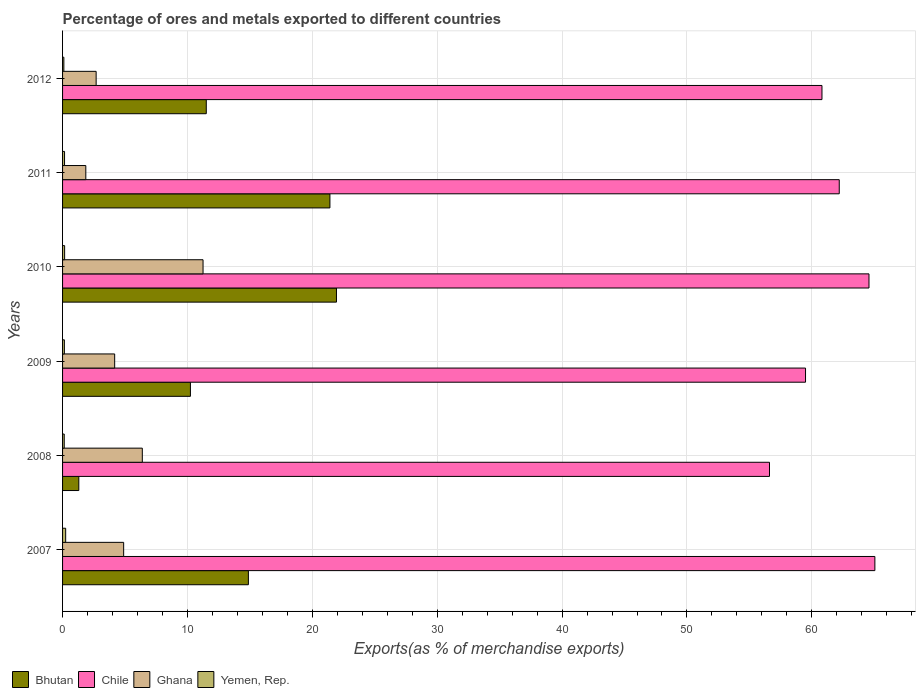Are the number of bars per tick equal to the number of legend labels?
Provide a succinct answer. Yes. How many bars are there on the 1st tick from the top?
Offer a very short reply. 4. How many bars are there on the 1st tick from the bottom?
Ensure brevity in your answer.  4. In how many cases, is the number of bars for a given year not equal to the number of legend labels?
Make the answer very short. 0. What is the percentage of exports to different countries in Chile in 2008?
Your answer should be very brief. 56.61. Across all years, what is the maximum percentage of exports to different countries in Ghana?
Your answer should be very brief. 11.25. Across all years, what is the minimum percentage of exports to different countries in Ghana?
Your response must be concise. 1.86. In which year was the percentage of exports to different countries in Chile maximum?
Your answer should be compact. 2007. In which year was the percentage of exports to different countries in Yemen, Rep. minimum?
Ensure brevity in your answer.  2012. What is the total percentage of exports to different countries in Yemen, Rep. in the graph?
Your response must be concise. 0.95. What is the difference between the percentage of exports to different countries in Chile in 2009 and that in 2010?
Keep it short and to the point. -5.08. What is the difference between the percentage of exports to different countries in Bhutan in 2008 and the percentage of exports to different countries in Yemen, Rep. in 2007?
Make the answer very short. 1.05. What is the average percentage of exports to different countries in Bhutan per year?
Provide a short and direct response. 13.55. In the year 2012, what is the difference between the percentage of exports to different countries in Bhutan and percentage of exports to different countries in Yemen, Rep.?
Ensure brevity in your answer.  11.4. What is the ratio of the percentage of exports to different countries in Yemen, Rep. in 2008 to that in 2011?
Provide a succinct answer. 0.85. Is the difference between the percentage of exports to different countries in Bhutan in 2008 and 2011 greater than the difference between the percentage of exports to different countries in Yemen, Rep. in 2008 and 2011?
Your response must be concise. No. What is the difference between the highest and the second highest percentage of exports to different countries in Yemen, Rep.?
Ensure brevity in your answer.  0.08. What is the difference between the highest and the lowest percentage of exports to different countries in Yemen, Rep.?
Give a very brief answer. 0.15. In how many years, is the percentage of exports to different countries in Chile greater than the average percentage of exports to different countries in Chile taken over all years?
Provide a short and direct response. 3. Is the sum of the percentage of exports to different countries in Yemen, Rep. in 2007 and 2012 greater than the maximum percentage of exports to different countries in Bhutan across all years?
Your answer should be compact. No. Is it the case that in every year, the sum of the percentage of exports to different countries in Yemen, Rep. and percentage of exports to different countries in Ghana is greater than the sum of percentage of exports to different countries in Chile and percentage of exports to different countries in Bhutan?
Your response must be concise. Yes. What does the 1st bar from the top in 2009 represents?
Your answer should be very brief. Yemen, Rep. What does the 1st bar from the bottom in 2009 represents?
Ensure brevity in your answer.  Bhutan. Is it the case that in every year, the sum of the percentage of exports to different countries in Ghana and percentage of exports to different countries in Bhutan is greater than the percentage of exports to different countries in Chile?
Provide a succinct answer. No. Are all the bars in the graph horizontal?
Provide a succinct answer. Yes. What is the difference between two consecutive major ticks on the X-axis?
Make the answer very short. 10. Are the values on the major ticks of X-axis written in scientific E-notation?
Provide a succinct answer. No. Does the graph contain any zero values?
Offer a very short reply. No. Does the graph contain grids?
Ensure brevity in your answer.  Yes. How many legend labels are there?
Make the answer very short. 4. What is the title of the graph?
Keep it short and to the point. Percentage of ores and metals exported to different countries. What is the label or title of the X-axis?
Provide a short and direct response. Exports(as % of merchandise exports). What is the label or title of the Y-axis?
Offer a terse response. Years. What is the Exports(as % of merchandise exports) in Bhutan in 2007?
Your answer should be very brief. 14.88. What is the Exports(as % of merchandise exports) in Chile in 2007?
Provide a succinct answer. 65.05. What is the Exports(as % of merchandise exports) of Ghana in 2007?
Your answer should be very brief. 4.89. What is the Exports(as % of merchandise exports) of Yemen, Rep. in 2007?
Ensure brevity in your answer.  0.25. What is the Exports(as % of merchandise exports) in Bhutan in 2008?
Offer a terse response. 1.3. What is the Exports(as % of merchandise exports) of Chile in 2008?
Make the answer very short. 56.61. What is the Exports(as % of merchandise exports) of Ghana in 2008?
Provide a succinct answer. 6.39. What is the Exports(as % of merchandise exports) of Yemen, Rep. in 2008?
Your answer should be very brief. 0.13. What is the Exports(as % of merchandise exports) of Bhutan in 2009?
Your answer should be compact. 10.24. What is the Exports(as % of merchandise exports) in Chile in 2009?
Your response must be concise. 59.49. What is the Exports(as % of merchandise exports) in Ghana in 2009?
Ensure brevity in your answer.  4.17. What is the Exports(as % of merchandise exports) of Yemen, Rep. in 2009?
Make the answer very short. 0.15. What is the Exports(as % of merchandise exports) in Bhutan in 2010?
Your response must be concise. 21.93. What is the Exports(as % of merchandise exports) in Chile in 2010?
Your answer should be very brief. 64.57. What is the Exports(as % of merchandise exports) in Ghana in 2010?
Offer a very short reply. 11.25. What is the Exports(as % of merchandise exports) in Yemen, Rep. in 2010?
Provide a short and direct response. 0.16. What is the Exports(as % of merchandise exports) of Bhutan in 2011?
Make the answer very short. 21.41. What is the Exports(as % of merchandise exports) of Chile in 2011?
Provide a succinct answer. 62.19. What is the Exports(as % of merchandise exports) of Ghana in 2011?
Offer a terse response. 1.86. What is the Exports(as % of merchandise exports) of Yemen, Rep. in 2011?
Offer a very short reply. 0.16. What is the Exports(as % of merchandise exports) of Bhutan in 2012?
Your response must be concise. 11.51. What is the Exports(as % of merchandise exports) in Chile in 2012?
Ensure brevity in your answer.  60.81. What is the Exports(as % of merchandise exports) of Ghana in 2012?
Ensure brevity in your answer.  2.69. What is the Exports(as % of merchandise exports) in Yemen, Rep. in 2012?
Provide a short and direct response. 0.1. Across all years, what is the maximum Exports(as % of merchandise exports) of Bhutan?
Provide a succinct answer. 21.93. Across all years, what is the maximum Exports(as % of merchandise exports) of Chile?
Offer a very short reply. 65.05. Across all years, what is the maximum Exports(as % of merchandise exports) of Ghana?
Your response must be concise. 11.25. Across all years, what is the maximum Exports(as % of merchandise exports) in Yemen, Rep.?
Your response must be concise. 0.25. Across all years, what is the minimum Exports(as % of merchandise exports) of Bhutan?
Your response must be concise. 1.3. Across all years, what is the minimum Exports(as % of merchandise exports) of Chile?
Ensure brevity in your answer.  56.61. Across all years, what is the minimum Exports(as % of merchandise exports) of Ghana?
Make the answer very short. 1.86. Across all years, what is the minimum Exports(as % of merchandise exports) in Yemen, Rep.?
Keep it short and to the point. 0.1. What is the total Exports(as % of merchandise exports) in Bhutan in the graph?
Offer a very short reply. 81.27. What is the total Exports(as % of merchandise exports) in Chile in the graph?
Keep it short and to the point. 368.73. What is the total Exports(as % of merchandise exports) in Ghana in the graph?
Your answer should be compact. 31.25. What is the total Exports(as % of merchandise exports) of Yemen, Rep. in the graph?
Make the answer very short. 0.95. What is the difference between the Exports(as % of merchandise exports) of Bhutan in 2007 and that in 2008?
Your response must be concise. 13.58. What is the difference between the Exports(as % of merchandise exports) in Chile in 2007 and that in 2008?
Provide a short and direct response. 8.44. What is the difference between the Exports(as % of merchandise exports) of Ghana in 2007 and that in 2008?
Make the answer very short. -1.49. What is the difference between the Exports(as % of merchandise exports) of Yemen, Rep. in 2007 and that in 2008?
Make the answer very short. 0.11. What is the difference between the Exports(as % of merchandise exports) of Bhutan in 2007 and that in 2009?
Make the answer very short. 4.64. What is the difference between the Exports(as % of merchandise exports) in Chile in 2007 and that in 2009?
Provide a succinct answer. 5.55. What is the difference between the Exports(as % of merchandise exports) of Ghana in 2007 and that in 2009?
Offer a terse response. 0.72. What is the difference between the Exports(as % of merchandise exports) of Yemen, Rep. in 2007 and that in 2009?
Offer a very short reply. 0.1. What is the difference between the Exports(as % of merchandise exports) in Bhutan in 2007 and that in 2010?
Give a very brief answer. -7.05. What is the difference between the Exports(as % of merchandise exports) in Chile in 2007 and that in 2010?
Ensure brevity in your answer.  0.47. What is the difference between the Exports(as % of merchandise exports) in Ghana in 2007 and that in 2010?
Your answer should be very brief. -6.36. What is the difference between the Exports(as % of merchandise exports) of Yemen, Rep. in 2007 and that in 2010?
Your answer should be very brief. 0.08. What is the difference between the Exports(as % of merchandise exports) in Bhutan in 2007 and that in 2011?
Keep it short and to the point. -6.53. What is the difference between the Exports(as % of merchandise exports) in Chile in 2007 and that in 2011?
Your answer should be compact. 2.85. What is the difference between the Exports(as % of merchandise exports) in Ghana in 2007 and that in 2011?
Keep it short and to the point. 3.03. What is the difference between the Exports(as % of merchandise exports) in Yemen, Rep. in 2007 and that in 2011?
Offer a very short reply. 0.09. What is the difference between the Exports(as % of merchandise exports) in Bhutan in 2007 and that in 2012?
Ensure brevity in your answer.  3.37. What is the difference between the Exports(as % of merchandise exports) of Chile in 2007 and that in 2012?
Provide a succinct answer. 4.24. What is the difference between the Exports(as % of merchandise exports) in Ghana in 2007 and that in 2012?
Offer a terse response. 2.2. What is the difference between the Exports(as % of merchandise exports) in Yemen, Rep. in 2007 and that in 2012?
Your response must be concise. 0.15. What is the difference between the Exports(as % of merchandise exports) of Bhutan in 2008 and that in 2009?
Your answer should be compact. -8.94. What is the difference between the Exports(as % of merchandise exports) in Chile in 2008 and that in 2009?
Keep it short and to the point. -2.88. What is the difference between the Exports(as % of merchandise exports) of Ghana in 2008 and that in 2009?
Your answer should be very brief. 2.21. What is the difference between the Exports(as % of merchandise exports) of Yemen, Rep. in 2008 and that in 2009?
Keep it short and to the point. -0.01. What is the difference between the Exports(as % of merchandise exports) in Bhutan in 2008 and that in 2010?
Your answer should be compact. -20.63. What is the difference between the Exports(as % of merchandise exports) of Chile in 2008 and that in 2010?
Give a very brief answer. -7.97. What is the difference between the Exports(as % of merchandise exports) of Ghana in 2008 and that in 2010?
Keep it short and to the point. -4.86. What is the difference between the Exports(as % of merchandise exports) of Yemen, Rep. in 2008 and that in 2010?
Offer a very short reply. -0.03. What is the difference between the Exports(as % of merchandise exports) in Bhutan in 2008 and that in 2011?
Your answer should be compact. -20.11. What is the difference between the Exports(as % of merchandise exports) in Chile in 2008 and that in 2011?
Make the answer very short. -5.59. What is the difference between the Exports(as % of merchandise exports) in Ghana in 2008 and that in 2011?
Your answer should be compact. 4.52. What is the difference between the Exports(as % of merchandise exports) in Yemen, Rep. in 2008 and that in 2011?
Give a very brief answer. -0.02. What is the difference between the Exports(as % of merchandise exports) of Bhutan in 2008 and that in 2012?
Ensure brevity in your answer.  -10.21. What is the difference between the Exports(as % of merchandise exports) of Chile in 2008 and that in 2012?
Provide a short and direct response. -4.2. What is the difference between the Exports(as % of merchandise exports) in Ghana in 2008 and that in 2012?
Your response must be concise. 3.7. What is the difference between the Exports(as % of merchandise exports) of Yemen, Rep. in 2008 and that in 2012?
Offer a terse response. 0.03. What is the difference between the Exports(as % of merchandise exports) of Bhutan in 2009 and that in 2010?
Your answer should be very brief. -11.7. What is the difference between the Exports(as % of merchandise exports) of Chile in 2009 and that in 2010?
Offer a very short reply. -5.08. What is the difference between the Exports(as % of merchandise exports) in Ghana in 2009 and that in 2010?
Ensure brevity in your answer.  -7.08. What is the difference between the Exports(as % of merchandise exports) in Yemen, Rep. in 2009 and that in 2010?
Offer a terse response. -0.02. What is the difference between the Exports(as % of merchandise exports) of Bhutan in 2009 and that in 2011?
Keep it short and to the point. -11.17. What is the difference between the Exports(as % of merchandise exports) in Chile in 2009 and that in 2011?
Keep it short and to the point. -2.7. What is the difference between the Exports(as % of merchandise exports) of Ghana in 2009 and that in 2011?
Your answer should be compact. 2.31. What is the difference between the Exports(as % of merchandise exports) of Yemen, Rep. in 2009 and that in 2011?
Make the answer very short. -0.01. What is the difference between the Exports(as % of merchandise exports) in Bhutan in 2009 and that in 2012?
Make the answer very short. -1.27. What is the difference between the Exports(as % of merchandise exports) in Chile in 2009 and that in 2012?
Ensure brevity in your answer.  -1.32. What is the difference between the Exports(as % of merchandise exports) in Ghana in 2009 and that in 2012?
Give a very brief answer. 1.48. What is the difference between the Exports(as % of merchandise exports) of Yemen, Rep. in 2009 and that in 2012?
Your answer should be compact. 0.04. What is the difference between the Exports(as % of merchandise exports) in Bhutan in 2010 and that in 2011?
Provide a succinct answer. 0.53. What is the difference between the Exports(as % of merchandise exports) of Chile in 2010 and that in 2011?
Offer a very short reply. 2.38. What is the difference between the Exports(as % of merchandise exports) in Ghana in 2010 and that in 2011?
Offer a terse response. 9.39. What is the difference between the Exports(as % of merchandise exports) in Yemen, Rep. in 2010 and that in 2011?
Provide a short and direct response. 0.01. What is the difference between the Exports(as % of merchandise exports) in Bhutan in 2010 and that in 2012?
Provide a succinct answer. 10.43. What is the difference between the Exports(as % of merchandise exports) in Chile in 2010 and that in 2012?
Offer a terse response. 3.76. What is the difference between the Exports(as % of merchandise exports) in Ghana in 2010 and that in 2012?
Keep it short and to the point. 8.56. What is the difference between the Exports(as % of merchandise exports) of Yemen, Rep. in 2010 and that in 2012?
Your answer should be compact. 0.06. What is the difference between the Exports(as % of merchandise exports) in Bhutan in 2011 and that in 2012?
Offer a very short reply. 9.9. What is the difference between the Exports(as % of merchandise exports) in Chile in 2011 and that in 2012?
Make the answer very short. 1.38. What is the difference between the Exports(as % of merchandise exports) in Ghana in 2011 and that in 2012?
Keep it short and to the point. -0.83. What is the difference between the Exports(as % of merchandise exports) of Yemen, Rep. in 2011 and that in 2012?
Give a very brief answer. 0.06. What is the difference between the Exports(as % of merchandise exports) of Bhutan in 2007 and the Exports(as % of merchandise exports) of Chile in 2008?
Your answer should be very brief. -41.73. What is the difference between the Exports(as % of merchandise exports) in Bhutan in 2007 and the Exports(as % of merchandise exports) in Ghana in 2008?
Offer a very short reply. 8.49. What is the difference between the Exports(as % of merchandise exports) in Bhutan in 2007 and the Exports(as % of merchandise exports) in Yemen, Rep. in 2008?
Your response must be concise. 14.75. What is the difference between the Exports(as % of merchandise exports) in Chile in 2007 and the Exports(as % of merchandise exports) in Ghana in 2008?
Offer a very short reply. 58.66. What is the difference between the Exports(as % of merchandise exports) of Chile in 2007 and the Exports(as % of merchandise exports) of Yemen, Rep. in 2008?
Offer a terse response. 64.91. What is the difference between the Exports(as % of merchandise exports) of Ghana in 2007 and the Exports(as % of merchandise exports) of Yemen, Rep. in 2008?
Ensure brevity in your answer.  4.76. What is the difference between the Exports(as % of merchandise exports) in Bhutan in 2007 and the Exports(as % of merchandise exports) in Chile in 2009?
Ensure brevity in your answer.  -44.61. What is the difference between the Exports(as % of merchandise exports) of Bhutan in 2007 and the Exports(as % of merchandise exports) of Ghana in 2009?
Give a very brief answer. 10.71. What is the difference between the Exports(as % of merchandise exports) of Bhutan in 2007 and the Exports(as % of merchandise exports) of Yemen, Rep. in 2009?
Provide a short and direct response. 14.74. What is the difference between the Exports(as % of merchandise exports) of Chile in 2007 and the Exports(as % of merchandise exports) of Ghana in 2009?
Offer a very short reply. 60.87. What is the difference between the Exports(as % of merchandise exports) of Chile in 2007 and the Exports(as % of merchandise exports) of Yemen, Rep. in 2009?
Ensure brevity in your answer.  64.9. What is the difference between the Exports(as % of merchandise exports) of Ghana in 2007 and the Exports(as % of merchandise exports) of Yemen, Rep. in 2009?
Your answer should be compact. 4.75. What is the difference between the Exports(as % of merchandise exports) in Bhutan in 2007 and the Exports(as % of merchandise exports) in Chile in 2010?
Your answer should be compact. -49.69. What is the difference between the Exports(as % of merchandise exports) in Bhutan in 2007 and the Exports(as % of merchandise exports) in Ghana in 2010?
Ensure brevity in your answer.  3.63. What is the difference between the Exports(as % of merchandise exports) in Bhutan in 2007 and the Exports(as % of merchandise exports) in Yemen, Rep. in 2010?
Offer a very short reply. 14.72. What is the difference between the Exports(as % of merchandise exports) of Chile in 2007 and the Exports(as % of merchandise exports) of Ghana in 2010?
Provide a succinct answer. 53.8. What is the difference between the Exports(as % of merchandise exports) of Chile in 2007 and the Exports(as % of merchandise exports) of Yemen, Rep. in 2010?
Provide a succinct answer. 64.88. What is the difference between the Exports(as % of merchandise exports) in Ghana in 2007 and the Exports(as % of merchandise exports) in Yemen, Rep. in 2010?
Your answer should be compact. 4.73. What is the difference between the Exports(as % of merchandise exports) in Bhutan in 2007 and the Exports(as % of merchandise exports) in Chile in 2011?
Ensure brevity in your answer.  -47.31. What is the difference between the Exports(as % of merchandise exports) in Bhutan in 2007 and the Exports(as % of merchandise exports) in Ghana in 2011?
Your answer should be compact. 13.02. What is the difference between the Exports(as % of merchandise exports) of Bhutan in 2007 and the Exports(as % of merchandise exports) of Yemen, Rep. in 2011?
Offer a very short reply. 14.72. What is the difference between the Exports(as % of merchandise exports) in Chile in 2007 and the Exports(as % of merchandise exports) in Ghana in 2011?
Offer a very short reply. 63.19. What is the difference between the Exports(as % of merchandise exports) of Chile in 2007 and the Exports(as % of merchandise exports) of Yemen, Rep. in 2011?
Give a very brief answer. 64.89. What is the difference between the Exports(as % of merchandise exports) in Ghana in 2007 and the Exports(as % of merchandise exports) in Yemen, Rep. in 2011?
Provide a succinct answer. 4.73. What is the difference between the Exports(as % of merchandise exports) of Bhutan in 2007 and the Exports(as % of merchandise exports) of Chile in 2012?
Provide a short and direct response. -45.93. What is the difference between the Exports(as % of merchandise exports) of Bhutan in 2007 and the Exports(as % of merchandise exports) of Ghana in 2012?
Provide a short and direct response. 12.19. What is the difference between the Exports(as % of merchandise exports) in Bhutan in 2007 and the Exports(as % of merchandise exports) in Yemen, Rep. in 2012?
Your response must be concise. 14.78. What is the difference between the Exports(as % of merchandise exports) in Chile in 2007 and the Exports(as % of merchandise exports) in Ghana in 2012?
Your answer should be very brief. 62.36. What is the difference between the Exports(as % of merchandise exports) in Chile in 2007 and the Exports(as % of merchandise exports) in Yemen, Rep. in 2012?
Provide a short and direct response. 64.94. What is the difference between the Exports(as % of merchandise exports) in Ghana in 2007 and the Exports(as % of merchandise exports) in Yemen, Rep. in 2012?
Give a very brief answer. 4.79. What is the difference between the Exports(as % of merchandise exports) of Bhutan in 2008 and the Exports(as % of merchandise exports) of Chile in 2009?
Keep it short and to the point. -58.19. What is the difference between the Exports(as % of merchandise exports) of Bhutan in 2008 and the Exports(as % of merchandise exports) of Ghana in 2009?
Your answer should be compact. -2.87. What is the difference between the Exports(as % of merchandise exports) of Bhutan in 2008 and the Exports(as % of merchandise exports) of Yemen, Rep. in 2009?
Offer a very short reply. 1.16. What is the difference between the Exports(as % of merchandise exports) of Chile in 2008 and the Exports(as % of merchandise exports) of Ghana in 2009?
Your answer should be compact. 52.44. What is the difference between the Exports(as % of merchandise exports) in Chile in 2008 and the Exports(as % of merchandise exports) in Yemen, Rep. in 2009?
Provide a short and direct response. 56.46. What is the difference between the Exports(as % of merchandise exports) of Ghana in 2008 and the Exports(as % of merchandise exports) of Yemen, Rep. in 2009?
Your answer should be very brief. 6.24. What is the difference between the Exports(as % of merchandise exports) in Bhutan in 2008 and the Exports(as % of merchandise exports) in Chile in 2010?
Your answer should be compact. -63.27. What is the difference between the Exports(as % of merchandise exports) in Bhutan in 2008 and the Exports(as % of merchandise exports) in Ghana in 2010?
Your answer should be very brief. -9.95. What is the difference between the Exports(as % of merchandise exports) of Bhutan in 2008 and the Exports(as % of merchandise exports) of Yemen, Rep. in 2010?
Make the answer very short. 1.14. What is the difference between the Exports(as % of merchandise exports) of Chile in 2008 and the Exports(as % of merchandise exports) of Ghana in 2010?
Ensure brevity in your answer.  45.36. What is the difference between the Exports(as % of merchandise exports) in Chile in 2008 and the Exports(as % of merchandise exports) in Yemen, Rep. in 2010?
Provide a short and direct response. 56.44. What is the difference between the Exports(as % of merchandise exports) of Ghana in 2008 and the Exports(as % of merchandise exports) of Yemen, Rep. in 2010?
Your answer should be very brief. 6.22. What is the difference between the Exports(as % of merchandise exports) of Bhutan in 2008 and the Exports(as % of merchandise exports) of Chile in 2011?
Give a very brief answer. -60.89. What is the difference between the Exports(as % of merchandise exports) of Bhutan in 2008 and the Exports(as % of merchandise exports) of Ghana in 2011?
Offer a terse response. -0.56. What is the difference between the Exports(as % of merchandise exports) of Bhutan in 2008 and the Exports(as % of merchandise exports) of Yemen, Rep. in 2011?
Offer a very short reply. 1.14. What is the difference between the Exports(as % of merchandise exports) in Chile in 2008 and the Exports(as % of merchandise exports) in Ghana in 2011?
Provide a short and direct response. 54.75. What is the difference between the Exports(as % of merchandise exports) in Chile in 2008 and the Exports(as % of merchandise exports) in Yemen, Rep. in 2011?
Offer a terse response. 56.45. What is the difference between the Exports(as % of merchandise exports) in Ghana in 2008 and the Exports(as % of merchandise exports) in Yemen, Rep. in 2011?
Your answer should be compact. 6.23. What is the difference between the Exports(as % of merchandise exports) of Bhutan in 2008 and the Exports(as % of merchandise exports) of Chile in 2012?
Your answer should be compact. -59.51. What is the difference between the Exports(as % of merchandise exports) of Bhutan in 2008 and the Exports(as % of merchandise exports) of Ghana in 2012?
Your answer should be compact. -1.39. What is the difference between the Exports(as % of merchandise exports) in Bhutan in 2008 and the Exports(as % of merchandise exports) in Yemen, Rep. in 2012?
Give a very brief answer. 1.2. What is the difference between the Exports(as % of merchandise exports) of Chile in 2008 and the Exports(as % of merchandise exports) of Ghana in 2012?
Your answer should be very brief. 53.92. What is the difference between the Exports(as % of merchandise exports) of Chile in 2008 and the Exports(as % of merchandise exports) of Yemen, Rep. in 2012?
Offer a very short reply. 56.51. What is the difference between the Exports(as % of merchandise exports) of Ghana in 2008 and the Exports(as % of merchandise exports) of Yemen, Rep. in 2012?
Give a very brief answer. 6.28. What is the difference between the Exports(as % of merchandise exports) in Bhutan in 2009 and the Exports(as % of merchandise exports) in Chile in 2010?
Your response must be concise. -54.34. What is the difference between the Exports(as % of merchandise exports) of Bhutan in 2009 and the Exports(as % of merchandise exports) of Ghana in 2010?
Ensure brevity in your answer.  -1.01. What is the difference between the Exports(as % of merchandise exports) of Bhutan in 2009 and the Exports(as % of merchandise exports) of Yemen, Rep. in 2010?
Your answer should be compact. 10.07. What is the difference between the Exports(as % of merchandise exports) in Chile in 2009 and the Exports(as % of merchandise exports) in Ghana in 2010?
Keep it short and to the point. 48.24. What is the difference between the Exports(as % of merchandise exports) in Chile in 2009 and the Exports(as % of merchandise exports) in Yemen, Rep. in 2010?
Ensure brevity in your answer.  59.33. What is the difference between the Exports(as % of merchandise exports) of Ghana in 2009 and the Exports(as % of merchandise exports) of Yemen, Rep. in 2010?
Make the answer very short. 4.01. What is the difference between the Exports(as % of merchandise exports) in Bhutan in 2009 and the Exports(as % of merchandise exports) in Chile in 2011?
Offer a terse response. -51.96. What is the difference between the Exports(as % of merchandise exports) of Bhutan in 2009 and the Exports(as % of merchandise exports) of Ghana in 2011?
Keep it short and to the point. 8.38. What is the difference between the Exports(as % of merchandise exports) in Bhutan in 2009 and the Exports(as % of merchandise exports) in Yemen, Rep. in 2011?
Your answer should be very brief. 10.08. What is the difference between the Exports(as % of merchandise exports) of Chile in 2009 and the Exports(as % of merchandise exports) of Ghana in 2011?
Your answer should be very brief. 57.63. What is the difference between the Exports(as % of merchandise exports) of Chile in 2009 and the Exports(as % of merchandise exports) of Yemen, Rep. in 2011?
Your answer should be compact. 59.34. What is the difference between the Exports(as % of merchandise exports) in Ghana in 2009 and the Exports(as % of merchandise exports) in Yemen, Rep. in 2011?
Your response must be concise. 4.01. What is the difference between the Exports(as % of merchandise exports) of Bhutan in 2009 and the Exports(as % of merchandise exports) of Chile in 2012?
Ensure brevity in your answer.  -50.57. What is the difference between the Exports(as % of merchandise exports) of Bhutan in 2009 and the Exports(as % of merchandise exports) of Ghana in 2012?
Your answer should be compact. 7.55. What is the difference between the Exports(as % of merchandise exports) of Bhutan in 2009 and the Exports(as % of merchandise exports) of Yemen, Rep. in 2012?
Offer a terse response. 10.14. What is the difference between the Exports(as % of merchandise exports) in Chile in 2009 and the Exports(as % of merchandise exports) in Ghana in 2012?
Keep it short and to the point. 56.8. What is the difference between the Exports(as % of merchandise exports) of Chile in 2009 and the Exports(as % of merchandise exports) of Yemen, Rep. in 2012?
Offer a very short reply. 59.39. What is the difference between the Exports(as % of merchandise exports) in Ghana in 2009 and the Exports(as % of merchandise exports) in Yemen, Rep. in 2012?
Make the answer very short. 4.07. What is the difference between the Exports(as % of merchandise exports) in Bhutan in 2010 and the Exports(as % of merchandise exports) in Chile in 2011?
Your response must be concise. -40.26. What is the difference between the Exports(as % of merchandise exports) of Bhutan in 2010 and the Exports(as % of merchandise exports) of Ghana in 2011?
Offer a very short reply. 20.07. What is the difference between the Exports(as % of merchandise exports) of Bhutan in 2010 and the Exports(as % of merchandise exports) of Yemen, Rep. in 2011?
Your answer should be compact. 21.78. What is the difference between the Exports(as % of merchandise exports) of Chile in 2010 and the Exports(as % of merchandise exports) of Ghana in 2011?
Give a very brief answer. 62.71. What is the difference between the Exports(as % of merchandise exports) in Chile in 2010 and the Exports(as % of merchandise exports) in Yemen, Rep. in 2011?
Offer a terse response. 64.42. What is the difference between the Exports(as % of merchandise exports) of Ghana in 2010 and the Exports(as % of merchandise exports) of Yemen, Rep. in 2011?
Provide a succinct answer. 11.09. What is the difference between the Exports(as % of merchandise exports) of Bhutan in 2010 and the Exports(as % of merchandise exports) of Chile in 2012?
Your answer should be compact. -38.88. What is the difference between the Exports(as % of merchandise exports) in Bhutan in 2010 and the Exports(as % of merchandise exports) in Ghana in 2012?
Make the answer very short. 19.24. What is the difference between the Exports(as % of merchandise exports) in Bhutan in 2010 and the Exports(as % of merchandise exports) in Yemen, Rep. in 2012?
Offer a very short reply. 21.83. What is the difference between the Exports(as % of merchandise exports) of Chile in 2010 and the Exports(as % of merchandise exports) of Ghana in 2012?
Offer a terse response. 61.89. What is the difference between the Exports(as % of merchandise exports) in Chile in 2010 and the Exports(as % of merchandise exports) in Yemen, Rep. in 2012?
Ensure brevity in your answer.  64.47. What is the difference between the Exports(as % of merchandise exports) in Ghana in 2010 and the Exports(as % of merchandise exports) in Yemen, Rep. in 2012?
Your response must be concise. 11.15. What is the difference between the Exports(as % of merchandise exports) in Bhutan in 2011 and the Exports(as % of merchandise exports) in Chile in 2012?
Give a very brief answer. -39.4. What is the difference between the Exports(as % of merchandise exports) in Bhutan in 2011 and the Exports(as % of merchandise exports) in Ghana in 2012?
Provide a short and direct response. 18.72. What is the difference between the Exports(as % of merchandise exports) in Bhutan in 2011 and the Exports(as % of merchandise exports) in Yemen, Rep. in 2012?
Your answer should be compact. 21.31. What is the difference between the Exports(as % of merchandise exports) in Chile in 2011 and the Exports(as % of merchandise exports) in Ghana in 2012?
Offer a very short reply. 59.51. What is the difference between the Exports(as % of merchandise exports) of Chile in 2011 and the Exports(as % of merchandise exports) of Yemen, Rep. in 2012?
Give a very brief answer. 62.09. What is the difference between the Exports(as % of merchandise exports) in Ghana in 2011 and the Exports(as % of merchandise exports) in Yemen, Rep. in 2012?
Offer a very short reply. 1.76. What is the average Exports(as % of merchandise exports) of Bhutan per year?
Give a very brief answer. 13.55. What is the average Exports(as % of merchandise exports) of Chile per year?
Ensure brevity in your answer.  61.46. What is the average Exports(as % of merchandise exports) of Ghana per year?
Your answer should be very brief. 5.21. What is the average Exports(as % of merchandise exports) of Yemen, Rep. per year?
Ensure brevity in your answer.  0.16. In the year 2007, what is the difference between the Exports(as % of merchandise exports) of Bhutan and Exports(as % of merchandise exports) of Chile?
Your answer should be very brief. -50.17. In the year 2007, what is the difference between the Exports(as % of merchandise exports) of Bhutan and Exports(as % of merchandise exports) of Ghana?
Ensure brevity in your answer.  9.99. In the year 2007, what is the difference between the Exports(as % of merchandise exports) in Bhutan and Exports(as % of merchandise exports) in Yemen, Rep.?
Ensure brevity in your answer.  14.63. In the year 2007, what is the difference between the Exports(as % of merchandise exports) in Chile and Exports(as % of merchandise exports) in Ghana?
Ensure brevity in your answer.  60.15. In the year 2007, what is the difference between the Exports(as % of merchandise exports) in Chile and Exports(as % of merchandise exports) in Yemen, Rep.?
Provide a short and direct response. 64.8. In the year 2007, what is the difference between the Exports(as % of merchandise exports) in Ghana and Exports(as % of merchandise exports) in Yemen, Rep.?
Provide a short and direct response. 4.64. In the year 2008, what is the difference between the Exports(as % of merchandise exports) in Bhutan and Exports(as % of merchandise exports) in Chile?
Keep it short and to the point. -55.31. In the year 2008, what is the difference between the Exports(as % of merchandise exports) in Bhutan and Exports(as % of merchandise exports) in Ghana?
Offer a terse response. -5.08. In the year 2008, what is the difference between the Exports(as % of merchandise exports) of Bhutan and Exports(as % of merchandise exports) of Yemen, Rep.?
Make the answer very short. 1.17. In the year 2008, what is the difference between the Exports(as % of merchandise exports) of Chile and Exports(as % of merchandise exports) of Ghana?
Make the answer very short. 50.22. In the year 2008, what is the difference between the Exports(as % of merchandise exports) in Chile and Exports(as % of merchandise exports) in Yemen, Rep.?
Offer a terse response. 56.48. In the year 2008, what is the difference between the Exports(as % of merchandise exports) in Ghana and Exports(as % of merchandise exports) in Yemen, Rep.?
Keep it short and to the point. 6.25. In the year 2009, what is the difference between the Exports(as % of merchandise exports) in Bhutan and Exports(as % of merchandise exports) in Chile?
Keep it short and to the point. -49.26. In the year 2009, what is the difference between the Exports(as % of merchandise exports) of Bhutan and Exports(as % of merchandise exports) of Ghana?
Provide a short and direct response. 6.07. In the year 2009, what is the difference between the Exports(as % of merchandise exports) of Bhutan and Exports(as % of merchandise exports) of Yemen, Rep.?
Offer a very short reply. 10.09. In the year 2009, what is the difference between the Exports(as % of merchandise exports) of Chile and Exports(as % of merchandise exports) of Ghana?
Offer a terse response. 55.32. In the year 2009, what is the difference between the Exports(as % of merchandise exports) in Chile and Exports(as % of merchandise exports) in Yemen, Rep.?
Your answer should be very brief. 59.35. In the year 2009, what is the difference between the Exports(as % of merchandise exports) of Ghana and Exports(as % of merchandise exports) of Yemen, Rep.?
Your answer should be compact. 4.03. In the year 2010, what is the difference between the Exports(as % of merchandise exports) of Bhutan and Exports(as % of merchandise exports) of Chile?
Provide a succinct answer. -42.64. In the year 2010, what is the difference between the Exports(as % of merchandise exports) in Bhutan and Exports(as % of merchandise exports) in Ghana?
Keep it short and to the point. 10.68. In the year 2010, what is the difference between the Exports(as % of merchandise exports) in Bhutan and Exports(as % of merchandise exports) in Yemen, Rep.?
Provide a succinct answer. 21.77. In the year 2010, what is the difference between the Exports(as % of merchandise exports) of Chile and Exports(as % of merchandise exports) of Ghana?
Your response must be concise. 53.33. In the year 2010, what is the difference between the Exports(as % of merchandise exports) of Chile and Exports(as % of merchandise exports) of Yemen, Rep.?
Offer a very short reply. 64.41. In the year 2010, what is the difference between the Exports(as % of merchandise exports) in Ghana and Exports(as % of merchandise exports) in Yemen, Rep.?
Ensure brevity in your answer.  11.09. In the year 2011, what is the difference between the Exports(as % of merchandise exports) in Bhutan and Exports(as % of merchandise exports) in Chile?
Ensure brevity in your answer.  -40.79. In the year 2011, what is the difference between the Exports(as % of merchandise exports) of Bhutan and Exports(as % of merchandise exports) of Ghana?
Give a very brief answer. 19.55. In the year 2011, what is the difference between the Exports(as % of merchandise exports) of Bhutan and Exports(as % of merchandise exports) of Yemen, Rep.?
Your response must be concise. 21.25. In the year 2011, what is the difference between the Exports(as % of merchandise exports) in Chile and Exports(as % of merchandise exports) in Ghana?
Offer a terse response. 60.33. In the year 2011, what is the difference between the Exports(as % of merchandise exports) in Chile and Exports(as % of merchandise exports) in Yemen, Rep.?
Offer a terse response. 62.04. In the year 2011, what is the difference between the Exports(as % of merchandise exports) of Ghana and Exports(as % of merchandise exports) of Yemen, Rep.?
Provide a short and direct response. 1.7. In the year 2012, what is the difference between the Exports(as % of merchandise exports) in Bhutan and Exports(as % of merchandise exports) in Chile?
Provide a short and direct response. -49.3. In the year 2012, what is the difference between the Exports(as % of merchandise exports) of Bhutan and Exports(as % of merchandise exports) of Ghana?
Offer a very short reply. 8.82. In the year 2012, what is the difference between the Exports(as % of merchandise exports) in Bhutan and Exports(as % of merchandise exports) in Yemen, Rep.?
Make the answer very short. 11.4. In the year 2012, what is the difference between the Exports(as % of merchandise exports) of Chile and Exports(as % of merchandise exports) of Ghana?
Make the answer very short. 58.12. In the year 2012, what is the difference between the Exports(as % of merchandise exports) of Chile and Exports(as % of merchandise exports) of Yemen, Rep.?
Your response must be concise. 60.71. In the year 2012, what is the difference between the Exports(as % of merchandise exports) of Ghana and Exports(as % of merchandise exports) of Yemen, Rep.?
Your response must be concise. 2.59. What is the ratio of the Exports(as % of merchandise exports) of Bhutan in 2007 to that in 2008?
Ensure brevity in your answer.  11.43. What is the ratio of the Exports(as % of merchandise exports) of Chile in 2007 to that in 2008?
Your response must be concise. 1.15. What is the ratio of the Exports(as % of merchandise exports) in Ghana in 2007 to that in 2008?
Make the answer very short. 0.77. What is the ratio of the Exports(as % of merchandise exports) in Yemen, Rep. in 2007 to that in 2008?
Your response must be concise. 1.85. What is the ratio of the Exports(as % of merchandise exports) of Bhutan in 2007 to that in 2009?
Offer a very short reply. 1.45. What is the ratio of the Exports(as % of merchandise exports) in Chile in 2007 to that in 2009?
Ensure brevity in your answer.  1.09. What is the ratio of the Exports(as % of merchandise exports) of Ghana in 2007 to that in 2009?
Give a very brief answer. 1.17. What is the ratio of the Exports(as % of merchandise exports) in Yemen, Rep. in 2007 to that in 2009?
Give a very brief answer. 1.71. What is the ratio of the Exports(as % of merchandise exports) in Bhutan in 2007 to that in 2010?
Your response must be concise. 0.68. What is the ratio of the Exports(as % of merchandise exports) in Chile in 2007 to that in 2010?
Make the answer very short. 1.01. What is the ratio of the Exports(as % of merchandise exports) in Ghana in 2007 to that in 2010?
Provide a short and direct response. 0.43. What is the ratio of the Exports(as % of merchandise exports) in Yemen, Rep. in 2007 to that in 2010?
Your response must be concise. 1.51. What is the ratio of the Exports(as % of merchandise exports) in Bhutan in 2007 to that in 2011?
Ensure brevity in your answer.  0.7. What is the ratio of the Exports(as % of merchandise exports) of Chile in 2007 to that in 2011?
Make the answer very short. 1.05. What is the ratio of the Exports(as % of merchandise exports) in Ghana in 2007 to that in 2011?
Keep it short and to the point. 2.63. What is the ratio of the Exports(as % of merchandise exports) in Yemen, Rep. in 2007 to that in 2011?
Offer a terse response. 1.57. What is the ratio of the Exports(as % of merchandise exports) in Bhutan in 2007 to that in 2012?
Give a very brief answer. 1.29. What is the ratio of the Exports(as % of merchandise exports) of Chile in 2007 to that in 2012?
Your response must be concise. 1.07. What is the ratio of the Exports(as % of merchandise exports) of Ghana in 2007 to that in 2012?
Your answer should be compact. 1.82. What is the ratio of the Exports(as % of merchandise exports) of Yemen, Rep. in 2007 to that in 2012?
Offer a very short reply. 2.41. What is the ratio of the Exports(as % of merchandise exports) of Bhutan in 2008 to that in 2009?
Offer a very short reply. 0.13. What is the ratio of the Exports(as % of merchandise exports) in Chile in 2008 to that in 2009?
Ensure brevity in your answer.  0.95. What is the ratio of the Exports(as % of merchandise exports) in Ghana in 2008 to that in 2009?
Your response must be concise. 1.53. What is the ratio of the Exports(as % of merchandise exports) of Yemen, Rep. in 2008 to that in 2009?
Your answer should be compact. 0.92. What is the ratio of the Exports(as % of merchandise exports) in Bhutan in 2008 to that in 2010?
Make the answer very short. 0.06. What is the ratio of the Exports(as % of merchandise exports) in Chile in 2008 to that in 2010?
Make the answer very short. 0.88. What is the ratio of the Exports(as % of merchandise exports) in Ghana in 2008 to that in 2010?
Keep it short and to the point. 0.57. What is the ratio of the Exports(as % of merchandise exports) in Yemen, Rep. in 2008 to that in 2010?
Provide a short and direct response. 0.81. What is the ratio of the Exports(as % of merchandise exports) of Bhutan in 2008 to that in 2011?
Your answer should be compact. 0.06. What is the ratio of the Exports(as % of merchandise exports) in Chile in 2008 to that in 2011?
Your answer should be compact. 0.91. What is the ratio of the Exports(as % of merchandise exports) of Ghana in 2008 to that in 2011?
Your answer should be very brief. 3.43. What is the ratio of the Exports(as % of merchandise exports) in Yemen, Rep. in 2008 to that in 2011?
Give a very brief answer. 0.85. What is the ratio of the Exports(as % of merchandise exports) in Bhutan in 2008 to that in 2012?
Provide a succinct answer. 0.11. What is the ratio of the Exports(as % of merchandise exports) in Chile in 2008 to that in 2012?
Offer a terse response. 0.93. What is the ratio of the Exports(as % of merchandise exports) in Ghana in 2008 to that in 2012?
Keep it short and to the point. 2.37. What is the ratio of the Exports(as % of merchandise exports) of Yemen, Rep. in 2008 to that in 2012?
Your answer should be very brief. 1.3. What is the ratio of the Exports(as % of merchandise exports) of Bhutan in 2009 to that in 2010?
Offer a terse response. 0.47. What is the ratio of the Exports(as % of merchandise exports) of Chile in 2009 to that in 2010?
Offer a terse response. 0.92. What is the ratio of the Exports(as % of merchandise exports) in Ghana in 2009 to that in 2010?
Offer a terse response. 0.37. What is the ratio of the Exports(as % of merchandise exports) of Yemen, Rep. in 2009 to that in 2010?
Your answer should be compact. 0.88. What is the ratio of the Exports(as % of merchandise exports) of Bhutan in 2009 to that in 2011?
Offer a very short reply. 0.48. What is the ratio of the Exports(as % of merchandise exports) in Chile in 2009 to that in 2011?
Offer a very short reply. 0.96. What is the ratio of the Exports(as % of merchandise exports) of Ghana in 2009 to that in 2011?
Ensure brevity in your answer.  2.24. What is the ratio of the Exports(as % of merchandise exports) of Yemen, Rep. in 2009 to that in 2011?
Your answer should be compact. 0.92. What is the ratio of the Exports(as % of merchandise exports) in Bhutan in 2009 to that in 2012?
Offer a very short reply. 0.89. What is the ratio of the Exports(as % of merchandise exports) in Chile in 2009 to that in 2012?
Make the answer very short. 0.98. What is the ratio of the Exports(as % of merchandise exports) of Ghana in 2009 to that in 2012?
Give a very brief answer. 1.55. What is the ratio of the Exports(as % of merchandise exports) in Yemen, Rep. in 2009 to that in 2012?
Your answer should be compact. 1.41. What is the ratio of the Exports(as % of merchandise exports) in Bhutan in 2010 to that in 2011?
Your answer should be compact. 1.02. What is the ratio of the Exports(as % of merchandise exports) in Chile in 2010 to that in 2011?
Your answer should be very brief. 1.04. What is the ratio of the Exports(as % of merchandise exports) of Ghana in 2010 to that in 2011?
Your response must be concise. 6.04. What is the ratio of the Exports(as % of merchandise exports) in Yemen, Rep. in 2010 to that in 2011?
Ensure brevity in your answer.  1.04. What is the ratio of the Exports(as % of merchandise exports) of Bhutan in 2010 to that in 2012?
Your answer should be compact. 1.91. What is the ratio of the Exports(as % of merchandise exports) in Chile in 2010 to that in 2012?
Offer a terse response. 1.06. What is the ratio of the Exports(as % of merchandise exports) in Ghana in 2010 to that in 2012?
Make the answer very short. 4.18. What is the ratio of the Exports(as % of merchandise exports) in Yemen, Rep. in 2010 to that in 2012?
Offer a terse response. 1.59. What is the ratio of the Exports(as % of merchandise exports) in Bhutan in 2011 to that in 2012?
Offer a terse response. 1.86. What is the ratio of the Exports(as % of merchandise exports) in Chile in 2011 to that in 2012?
Offer a terse response. 1.02. What is the ratio of the Exports(as % of merchandise exports) in Ghana in 2011 to that in 2012?
Offer a terse response. 0.69. What is the ratio of the Exports(as % of merchandise exports) of Yemen, Rep. in 2011 to that in 2012?
Make the answer very short. 1.53. What is the difference between the highest and the second highest Exports(as % of merchandise exports) in Bhutan?
Provide a succinct answer. 0.53. What is the difference between the highest and the second highest Exports(as % of merchandise exports) of Chile?
Give a very brief answer. 0.47. What is the difference between the highest and the second highest Exports(as % of merchandise exports) of Ghana?
Keep it short and to the point. 4.86. What is the difference between the highest and the second highest Exports(as % of merchandise exports) in Yemen, Rep.?
Keep it short and to the point. 0.08. What is the difference between the highest and the lowest Exports(as % of merchandise exports) of Bhutan?
Provide a short and direct response. 20.63. What is the difference between the highest and the lowest Exports(as % of merchandise exports) in Chile?
Ensure brevity in your answer.  8.44. What is the difference between the highest and the lowest Exports(as % of merchandise exports) in Ghana?
Give a very brief answer. 9.39. What is the difference between the highest and the lowest Exports(as % of merchandise exports) of Yemen, Rep.?
Make the answer very short. 0.15. 